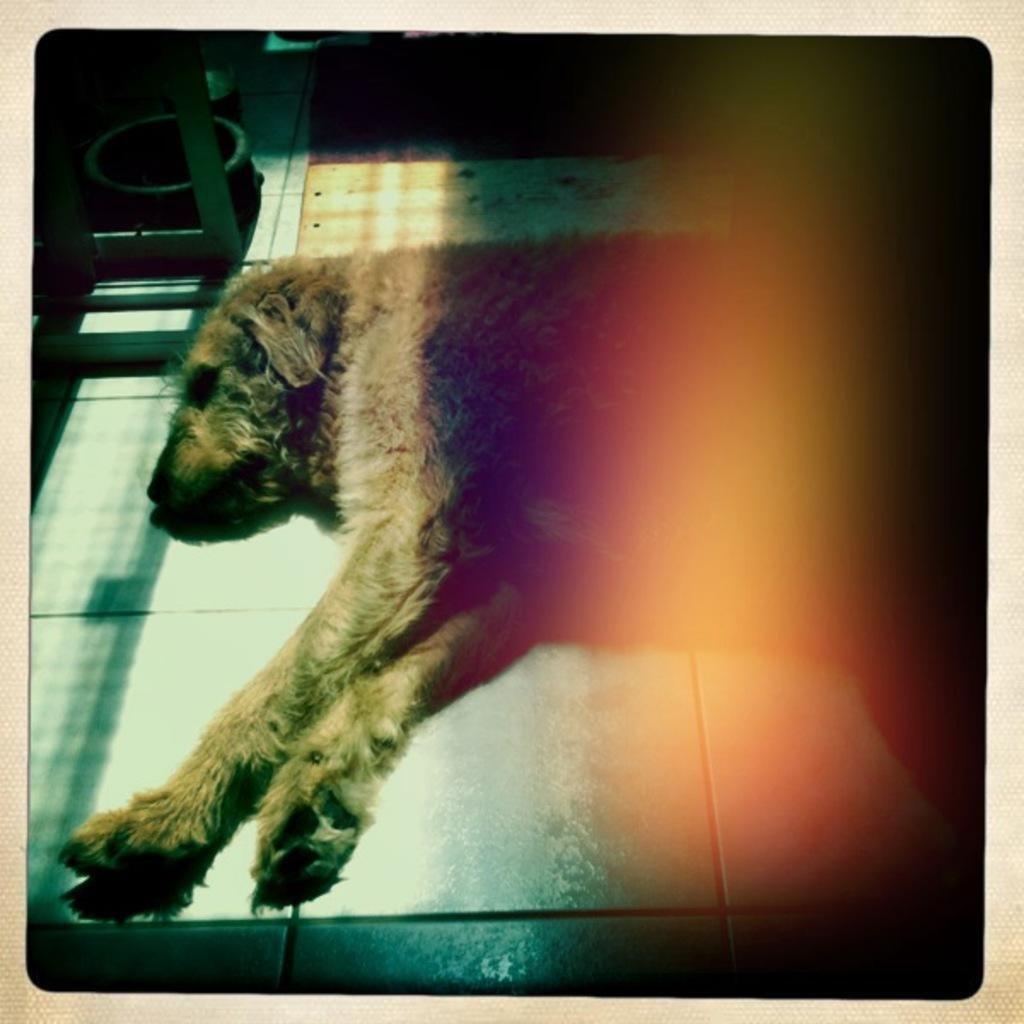What animal can be seen in the image? There is a dog in the image. Where is the dog positioned in the image? The dog is lying on a platform. What object is present in the image that might be used for holding food or water? There is a bowl in the image. What long, thin object can be seen in the image? There is a rod in the image. How would you describe the lighting in the image? The background of the image is dark. How many teeth can be seen on the shelf in the image? There is no shelf or teeth present in the image. What type of riddle can be solved by looking at the dog in the image? There is no riddle associated with the dog in the image. 